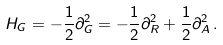Convert formula to latex. <formula><loc_0><loc_0><loc_500><loc_500>H _ { G } = - \frac { 1 } { 2 } \partial _ { G } ^ { 2 } = - \frac { 1 } { 2 } \partial _ { R } ^ { 2 } + \frac { 1 } { 2 } \partial _ { A } ^ { 2 } \, .</formula> 